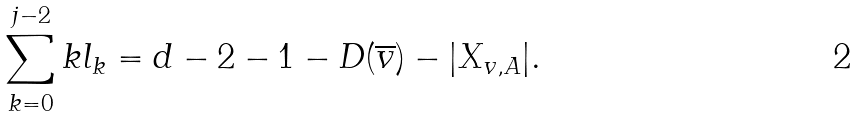Convert formula to latex. <formula><loc_0><loc_0><loc_500><loc_500>\sum _ { k = 0 } ^ { j - 2 } k l _ { k } = d - 2 - 1 - D ( \overline { v } ) - | X _ { v , A } | .</formula> 